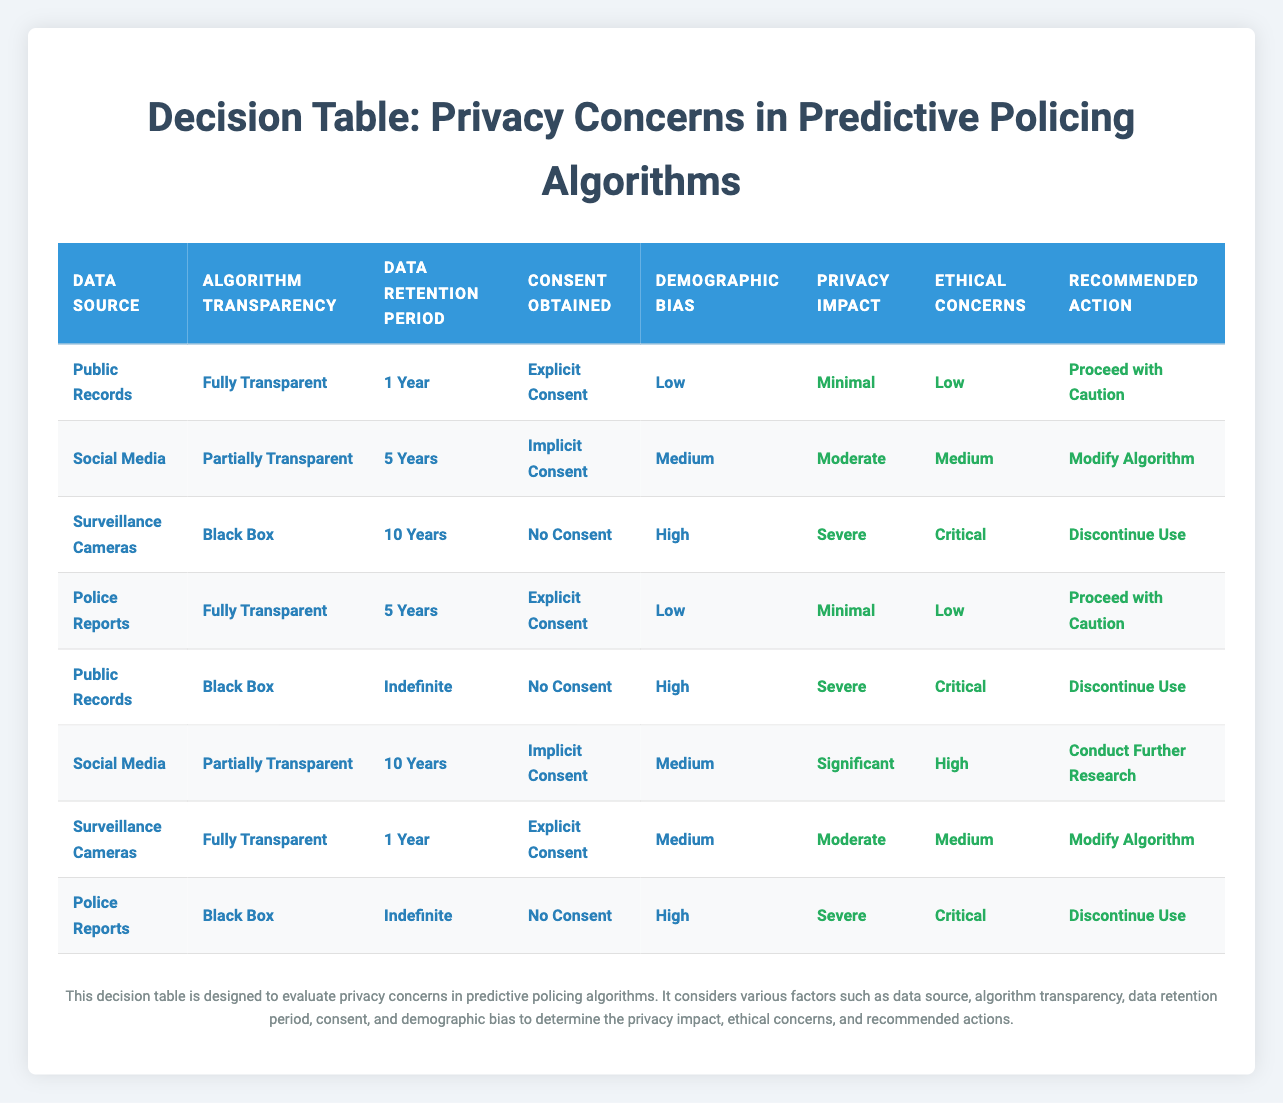What is the privacy impact of using surveillance cameras without obtaining consent? According to the table, the row for surveillance cameras indicates a "Severe" privacy impact when there is no consent obtained.
Answer: Severe Which data source has the lowest privacy impact when combined with explicit consent? The table shows that both Public Records and Police Reports have a "Minimal" privacy impact when combined with explicit consent.
Answer: Public Records and Police Reports What is the recommended action for predictive policing algorithms using social media with medium demographic bias? The row corresponding to social media with medium demographic bias indicates the recommended action is to "Modify Algorithm".
Answer: Modify Algorithm Is there any scenario listed where the ethical concerns are categorized as critical? Yes, the table shows two scenarios where the ethical concerns are critical: using surveillance cameras with no consent and using public records with indefinite retention without consent.
Answer: Yes What is the average privacy impact across all scenarios that obtain explicit consent? The scenarios with explicit consent are Public Records (Minimal), Surveillance Cameras (Moderate), and Police Reports (Minimal). The privacy impact scores are: Minimal (1), Moderate (2), Minimal (1). Total score = 1 + 2 + 1 = 4. There are 3 scenarios, so the average privacy impact score is 4/3 = 1.33, which we can round to “Moderate”.
Answer: Moderate What action is recommended for police reports with a black box algorithm and no consent? The table specifies that for police reports with a black box algorithm and no consent, the recommended action is to "Discontinue Use".
Answer: Discontinue Use Are there any combinations of data source and data retention period that lead to a significant privacy impact? Yes, the row for social media with a 10-year retention period leads to a "Significant" privacy impact.
Answer: Yes What is the highest duration of the data retention period across all scenarios that leads to severe privacy impact? The table indicates that the highest data retention period leading to a severe privacy impact occurs in the row for public records with an indefinite data retention period.
Answer: Indefinite 